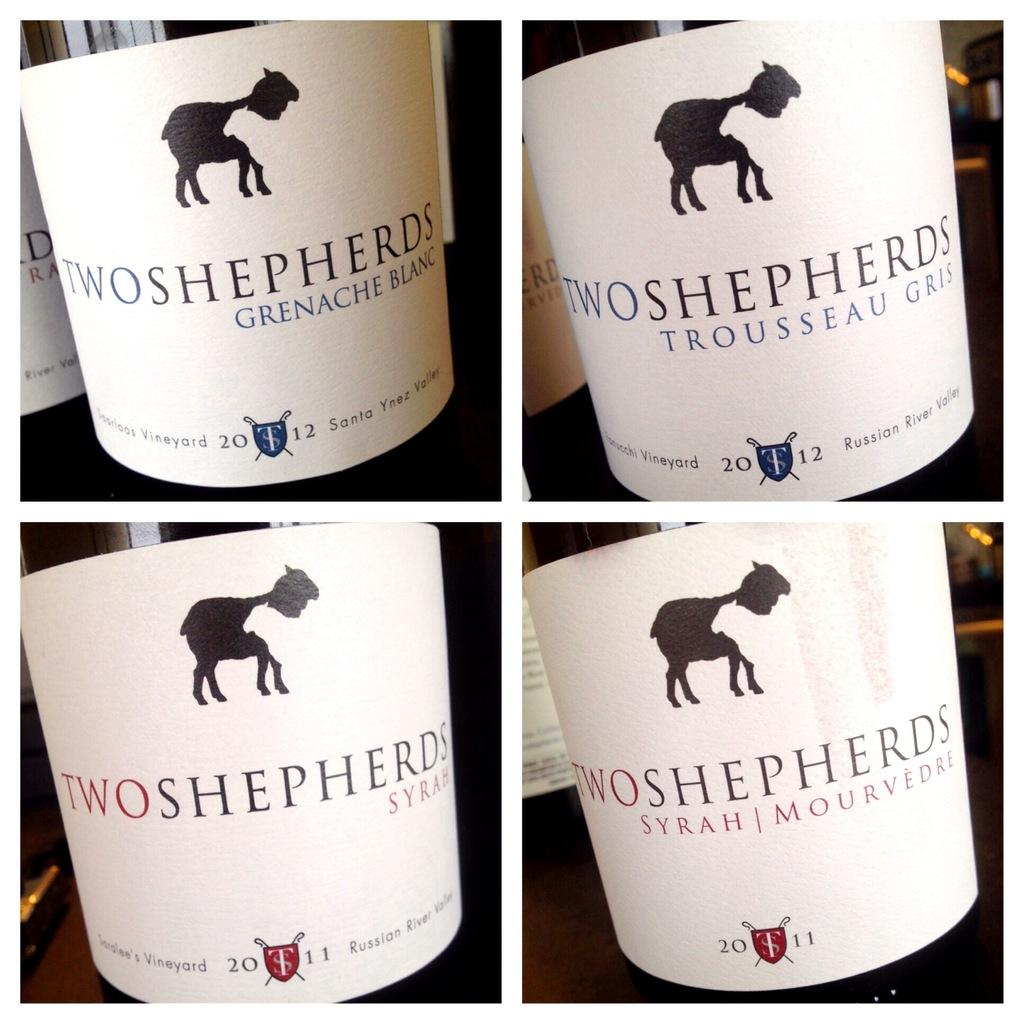How many pictures are present in the image? There are four pictures in the image. What is common among the objects in each picture? Each picture contains a bottle with a label. Where are the bottles placed in the image? The bottles are placed on a surface. Can you describe the background of the image? There are more bottles with labels in the background of the image. What type of cherry is used to label the bottles in the image? There is no cherry present in the image; the labels on the bottles cannot be determined from the provided facts. 